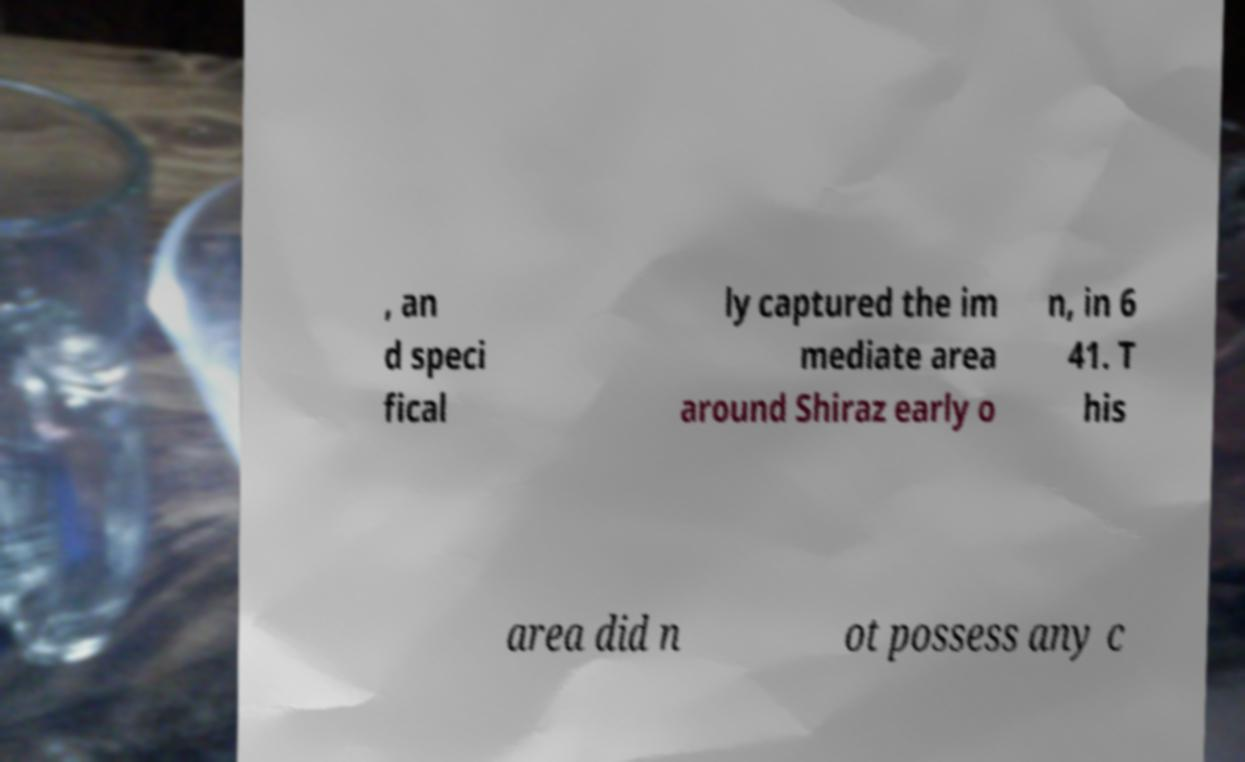There's text embedded in this image that I need extracted. Can you transcribe it verbatim? , an d speci fical ly captured the im mediate area around Shiraz early o n, in 6 41. T his area did n ot possess any c 